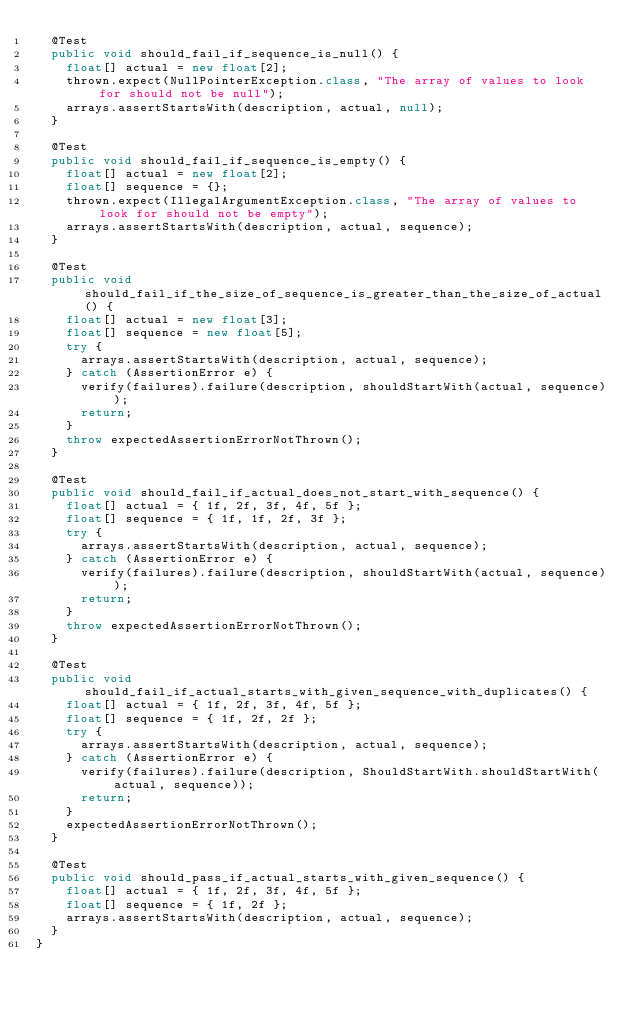<code> <loc_0><loc_0><loc_500><loc_500><_Java_>  @Test
  public void should_fail_if_sequence_is_null() {
    float[] actual = new float[2];
    thrown.expect(NullPointerException.class, "The array of values to look for should not be null");
    arrays.assertStartsWith(description, actual, null);
  }

  @Test
  public void should_fail_if_sequence_is_empty() {
    float[] actual = new float[2];
    float[] sequence = {};
    thrown.expect(IllegalArgumentException.class, "The array of values to look for should not be empty");
    arrays.assertStartsWith(description, actual, sequence);
  }

  @Test
  public void should_fail_if_the_size_of_sequence_is_greater_than_the_size_of_actual() {
    float[] actual = new float[3];
    float[] sequence = new float[5];
    try {
      arrays.assertStartsWith(description, actual, sequence);
    } catch (AssertionError e) {
      verify(failures).failure(description, shouldStartWith(actual, sequence));
      return;
    }
    throw expectedAssertionErrorNotThrown();
  }

  @Test
  public void should_fail_if_actual_does_not_start_with_sequence() {
    float[] actual = { 1f, 2f, 3f, 4f, 5f };
    float[] sequence = { 1f, 1f, 2f, 3f };
    try {
      arrays.assertStartsWith(description, actual, sequence);
    } catch (AssertionError e) {
      verify(failures).failure(description, shouldStartWith(actual, sequence));
      return;
    }
    throw expectedAssertionErrorNotThrown();
  }

  @Test
  public void should_fail_if_actual_starts_with_given_sequence_with_duplicates() {
    float[] actual = { 1f, 2f, 3f, 4f, 5f };
    float[] sequence = { 1f, 2f, 2f };
    try {
      arrays.assertStartsWith(description, actual, sequence);
    } catch (AssertionError e) {
      verify(failures).failure(description, ShouldStartWith.shouldStartWith(actual, sequence));
      return;
    }
    expectedAssertionErrorNotThrown();
  }

  @Test
  public void should_pass_if_actual_starts_with_given_sequence() {
    float[] actual = { 1f, 2f, 3f, 4f, 5f };
    float[] sequence = { 1f, 2f };
    arrays.assertStartsWith(description, actual, sequence);
  }
}
</code> 